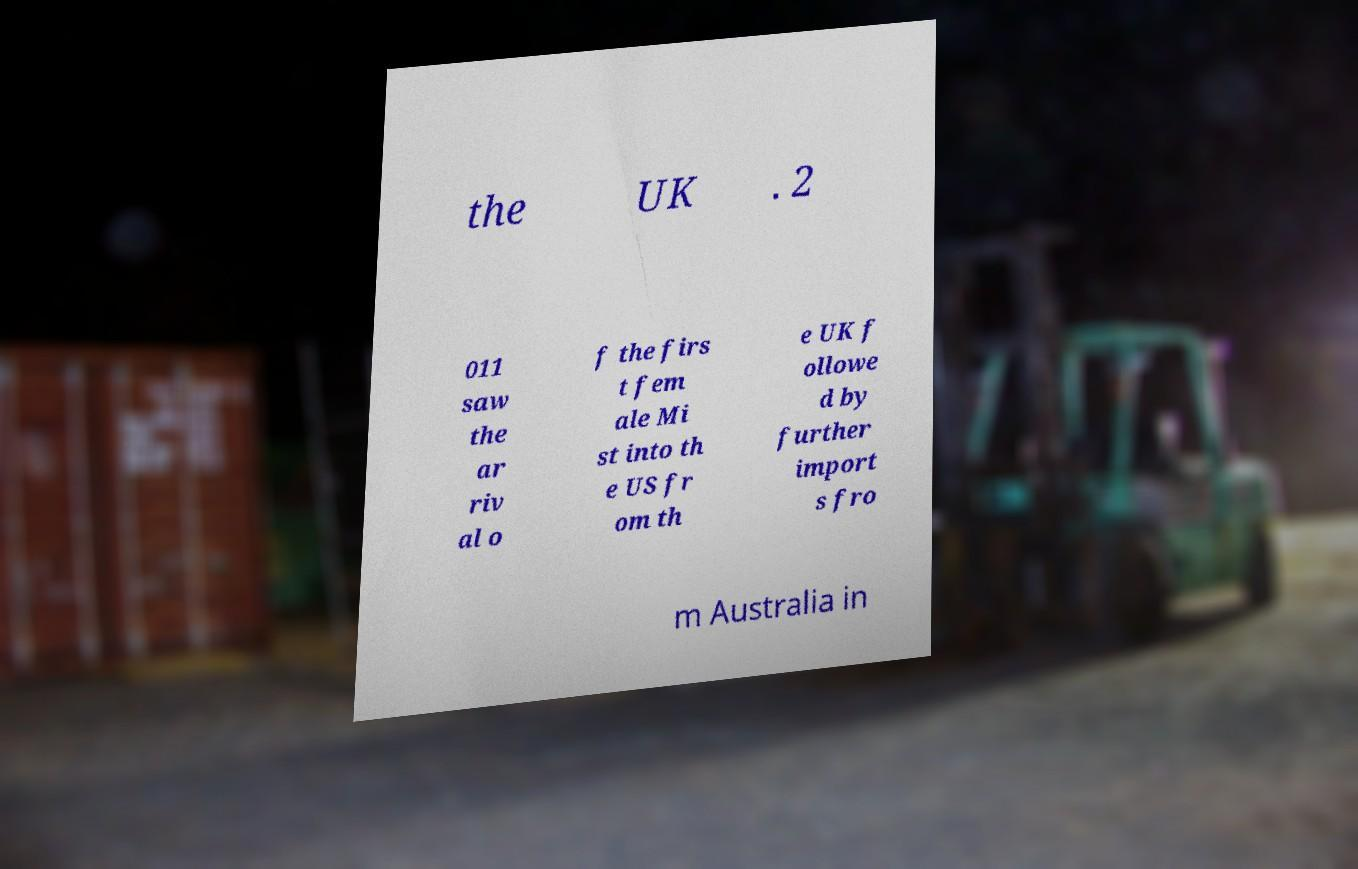Can you accurately transcribe the text from the provided image for me? the UK . 2 011 saw the ar riv al o f the firs t fem ale Mi st into th e US fr om th e UK f ollowe d by further import s fro m Australia in 